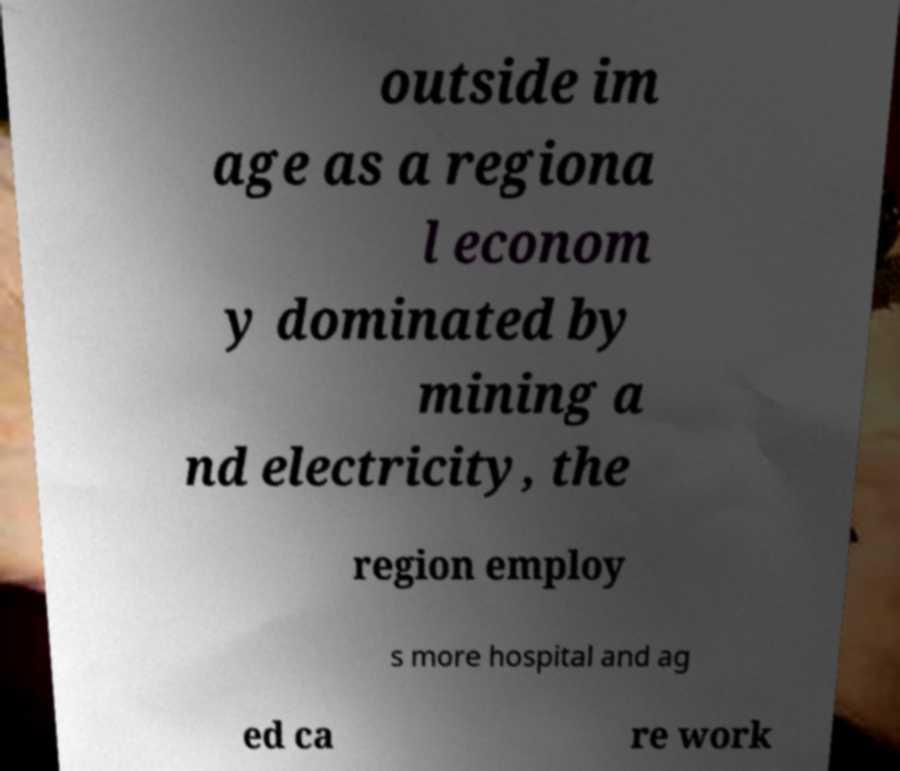For documentation purposes, I need the text within this image transcribed. Could you provide that? outside im age as a regiona l econom y dominated by mining a nd electricity, the region employ s more hospital and ag ed ca re work 